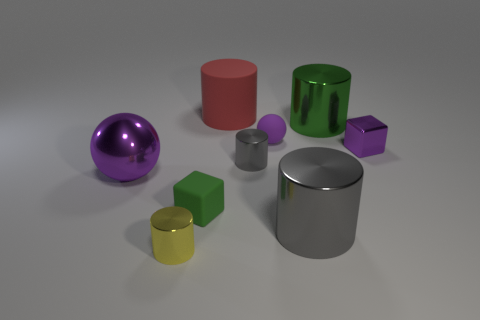What size is the metallic ball that is the same color as the metallic cube?
Provide a short and direct response. Large. There is a big green shiny thing behind the purple object to the left of the green thing in front of the large green shiny cylinder; what shape is it?
Provide a succinct answer. Cylinder. What number of objects are purple shiny things or cylinders behind the green metallic thing?
Give a very brief answer. 3. Do the green object in front of the metallic cube and the big metallic object on the right side of the large gray shiny object have the same shape?
Offer a very short reply. No. What number of things are tiny gray rubber balls or small yellow shiny objects?
Make the answer very short. 1. Are there any other things that are the same material as the red thing?
Offer a very short reply. Yes. Are there any big blue shiny things?
Offer a very short reply. No. Are the gray thing in front of the large shiny sphere and the purple cube made of the same material?
Provide a short and direct response. Yes. Is there a large gray matte thing that has the same shape as the large green object?
Your answer should be very brief. No. Are there an equal number of purple balls behind the tiny purple rubber sphere and large green shiny objects?
Your answer should be very brief. No. 